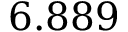Convert formula to latex. <formula><loc_0><loc_0><loc_500><loc_500>6 . 8 8 9</formula> 